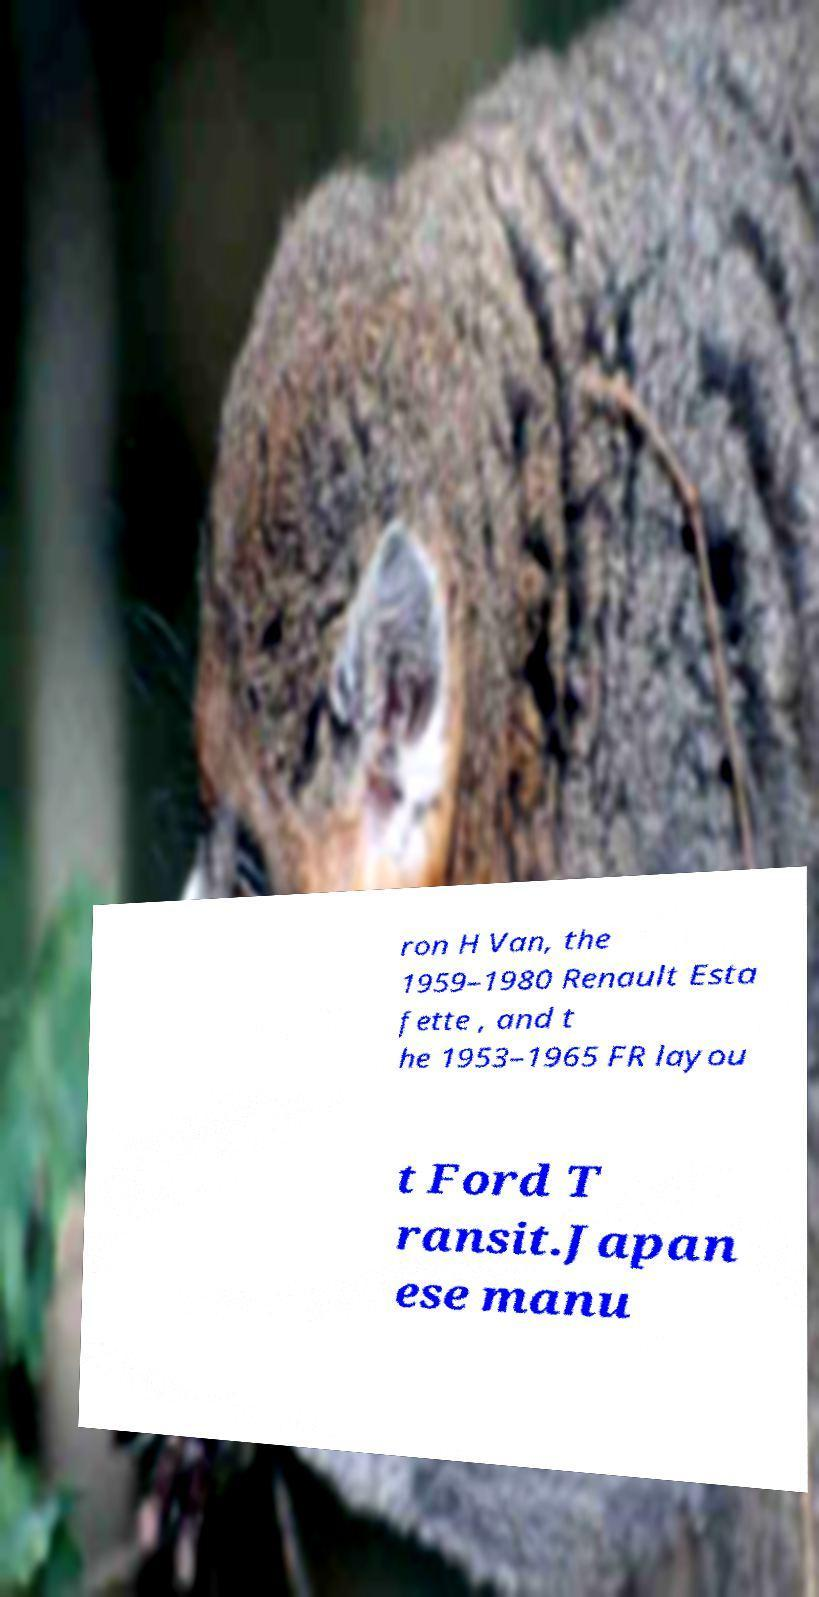There's text embedded in this image that I need extracted. Can you transcribe it verbatim? ron H Van, the 1959–1980 Renault Esta fette , and t he 1953–1965 FR layou t Ford T ransit.Japan ese manu 